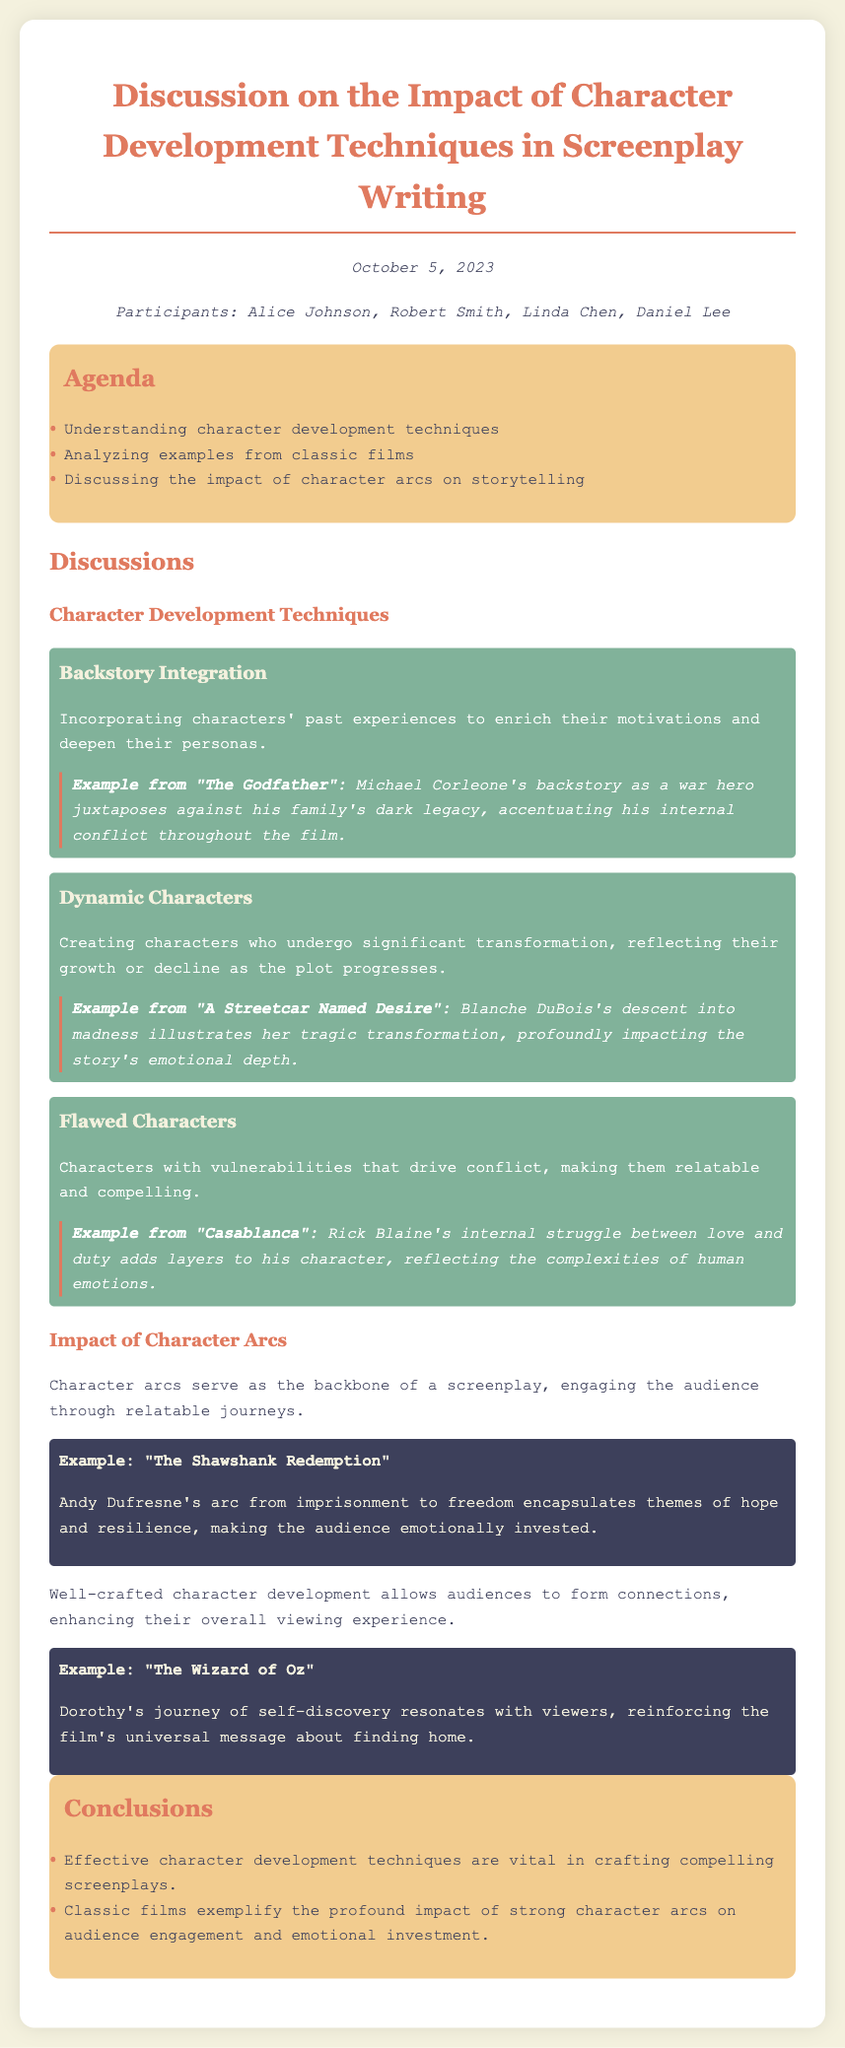What was the date of the meeting? The date of the meeting is prominently featured at the top of the document.
Answer: October 5, 2023 Who are the participants of the meeting? The participants are listed in the section immediately following the date.
Answer: Alice Johnson, Robert Smith, Linda Chen, Daniel Lee What technique is described as incorporating characters' past experiences? The document explicitly defines this character development technique in the discussion section.
Answer: Backstory Integration Which classic film is used as an example for Dynamic Characters? The document provides specific examples related to each technique, including this one.
Answer: A Streetcar Named Desire What character arc is highlighted in "The Shawshank Redemption"? This information is detailed under the Impact section discussing character arcs.
Answer: from imprisonment to freedom How do effective character development techniques affect audience engagement? The conclusions section summarizes the document's findings on the relationship between character development and audience experience.
Answer: vital in crafting compelling screenplays What is the universal message reinforced by Dorothy's journey in "The Wizard of Oz"? The document provides insights into the impact of character arcs on the audience through Dorothy's journey.
Answer: finding home 